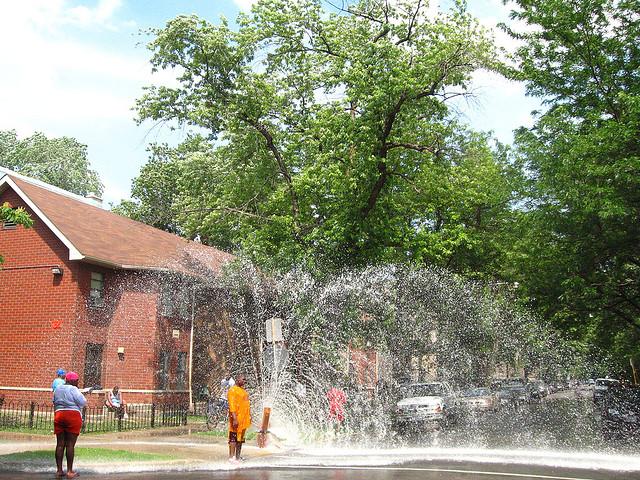Did the fire hydrant break?
Be succinct. Yes. What color is the car immediately behind the water?
Keep it brief. White. Is the water clean?
Quick response, please. Yes. 